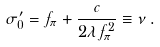<formula> <loc_0><loc_0><loc_500><loc_500>\sigma _ { 0 } ^ { \prime } = f _ { \pi } + \frac { c } { 2 \lambda f _ { \pi } ^ { 2 } } \equiv \nu \, .</formula> 